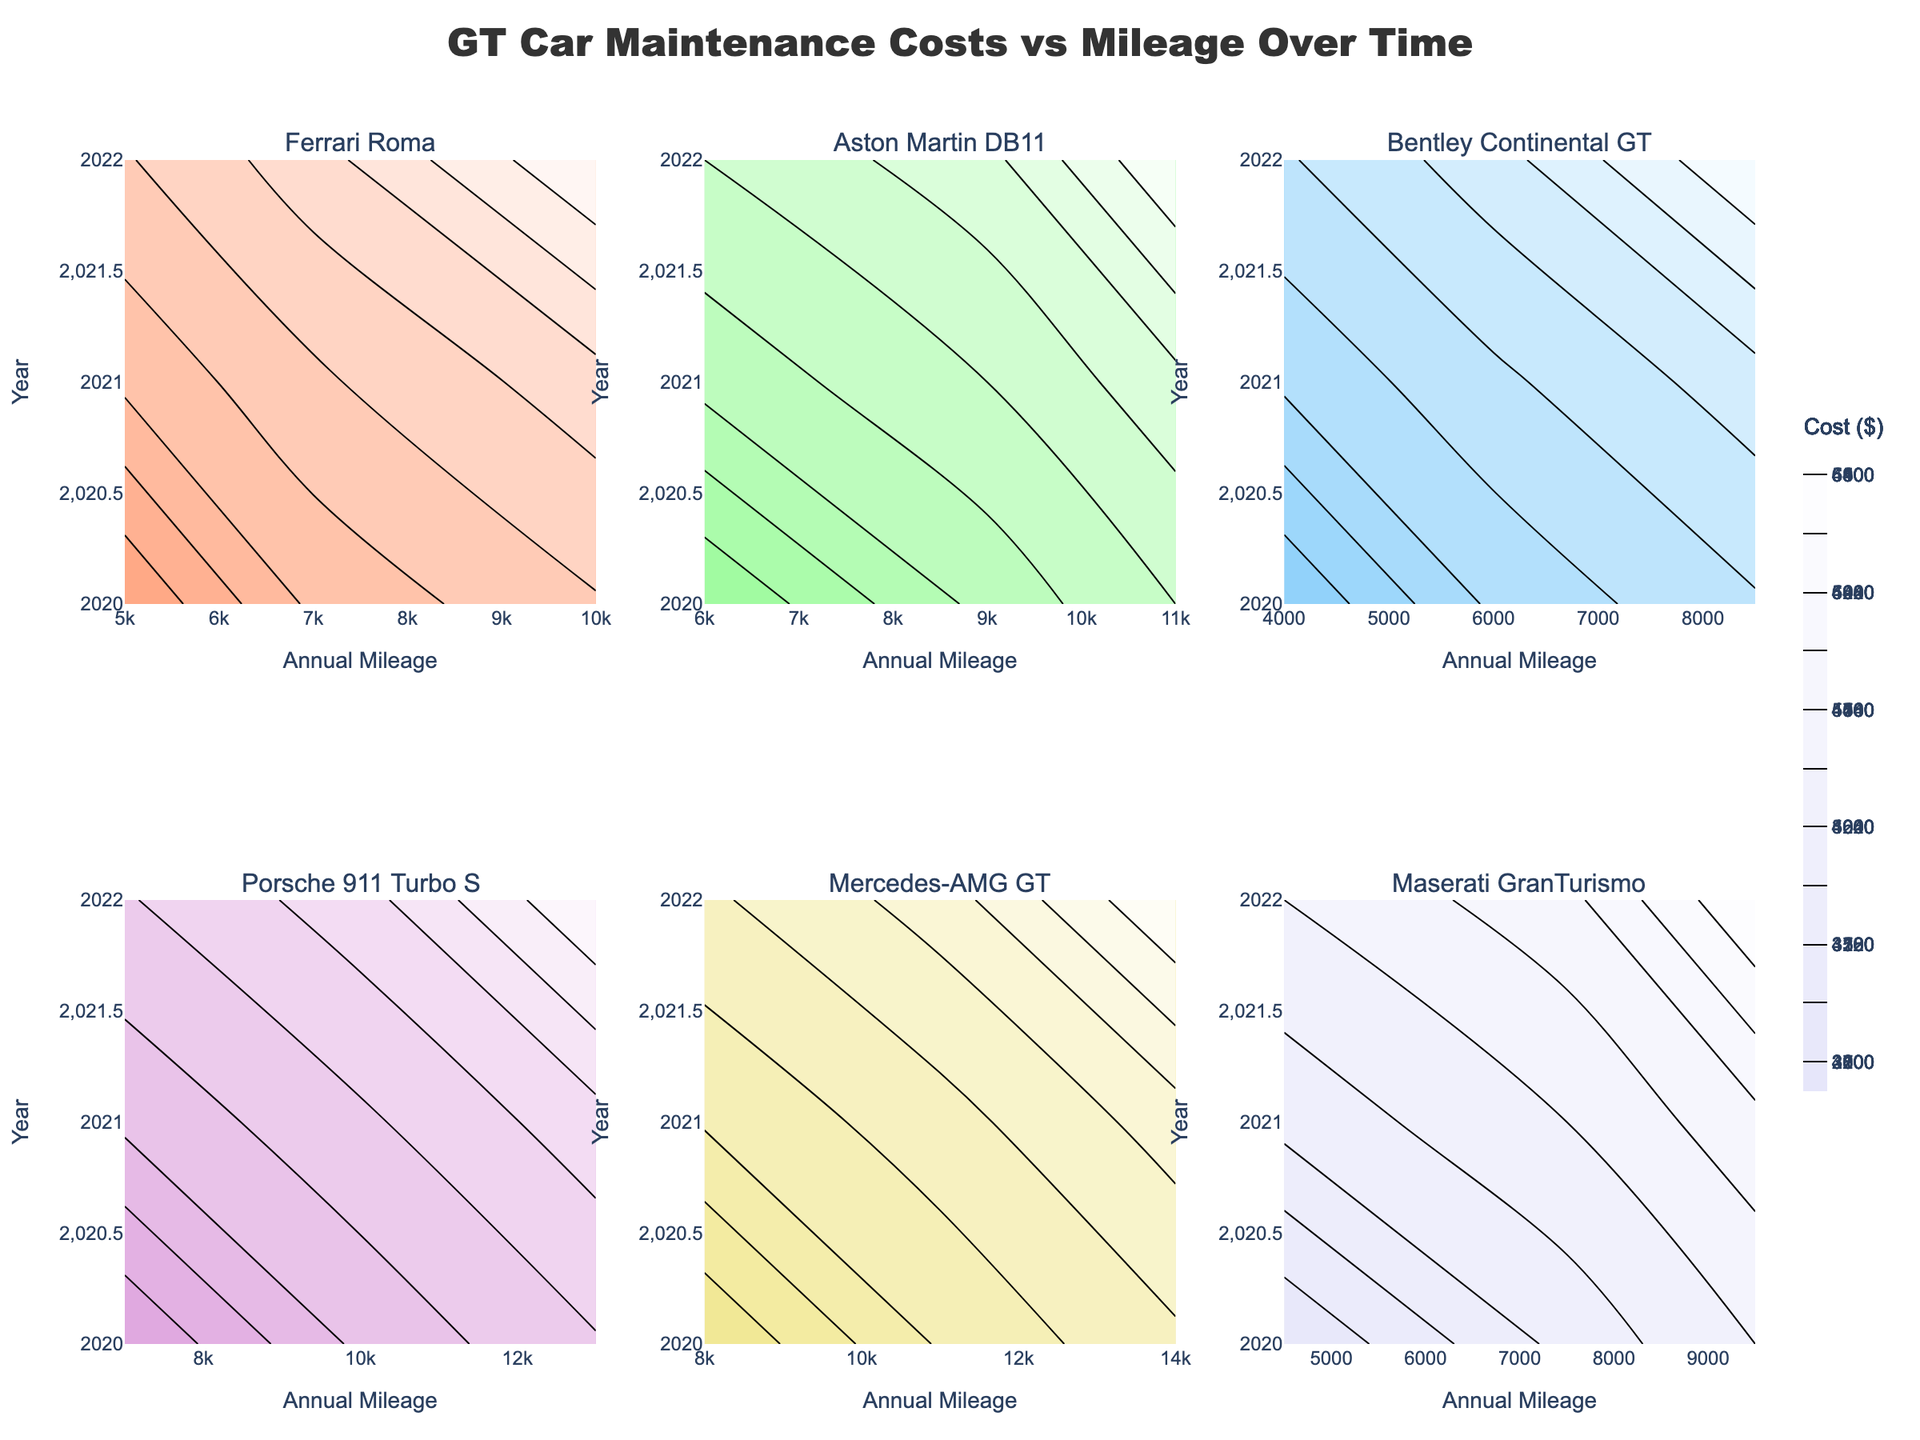What's the title of the figure? The title of the figure is positioned at the top, indicating the main topic of the visual data. The title is "GT Car Maintenance Costs vs Mileage Over Time".
Answer: GT Car Maintenance Costs vs Mileage Over Time How does the Ferrari Roma's maintenance cost trend over the years? Examine the contour plot of the Ferrari Roma. The maintenance cost increases from one year to the next, starting from $3000 in 2020 to higher values in subsequent years.
Answer: Increases Which car model had the highest maintenance cost in 2022? Look at the z-axis values for each car model in the 2022 columns of the subplots. Compare each to find the highest value. The Porsche 911 Turbo S has the highest maintenance cost in 2022 with around $6500.
Answer: Porsche 911 Turbo S What range of annual mileage was recorded for the Bentley Continental GT in 2021? Check the x-axis on the Bentley Continental GT subplot for data points corresponding to the year 2021. The annual mileage is 6000 miles.
Answer: 6000 miles How does the maintenance cost of the Mercedes-AMG GT change from 2020 to 2022? Examine the Mercedes-AMG GT subplot and observe the contour lines from 2020 to 2022. The maintenance cost shows an increase over these years, going from approximately $3700 in 2020 to $6100 in 2022.
Answer: Increases Which car model had the lowest maintenance cost in 2020 and what was it? Look at the z-axis values for each car model in the 2020 rows of the subplots. The Bentley Continental GT had the lowest maintenance cost, around $2800, in 2020.
Answer: Bentley Continental GT, $2800 How does the contour color for maintenance cost differ between Ferrari Roma and Maserati GranTurismo? Compare the contour colors used for Ferrari Roma and Maserati GranTurismo. Ferrari Roma might use a certain shade that ranges from salmon pink to white, while Maserati GranTurismo shows another specific color gradient.
Answer: Different color gradients Between Aston Martin DB11 and Maserati GranTurismo, which had a higher increase in maintenance costs from 2021 to 2022? Calculate the difference in maintenance costs between 2021 and 2022 for both models. Aston Martin DB11 increased from $4500 to $5800, a $1300 increase. Maserati GranTurismo increased from $4250 to $5400, a $1150 increase. Thus, Aston Martin DB11 had a higher increase.
Answer: Aston Martin DB11 